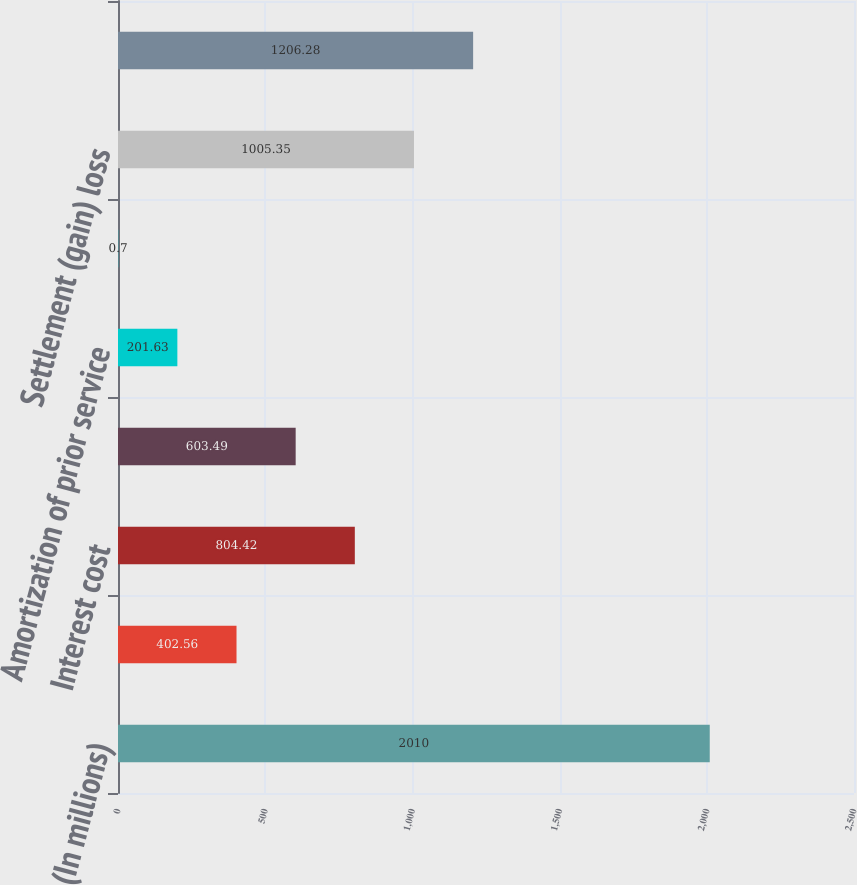Convert chart. <chart><loc_0><loc_0><loc_500><loc_500><bar_chart><fcel>(In millions)<fcel>Service cost<fcel>Interest cost<fcel>Expected return on plan assets<fcel>Amortization of prior service<fcel>Recognized actuarial loss<fcel>Settlement (gain) loss<fcel>Net periodic benefit cost<nl><fcel>2010<fcel>402.56<fcel>804.42<fcel>603.49<fcel>201.63<fcel>0.7<fcel>1005.35<fcel>1206.28<nl></chart> 